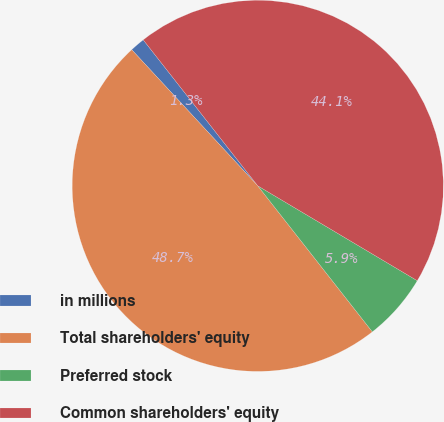Convert chart to OTSL. <chart><loc_0><loc_0><loc_500><loc_500><pie_chart><fcel>in millions<fcel>Total shareholders' equity<fcel>Preferred stock<fcel>Common shareholders' equity<nl><fcel>1.3%<fcel>48.7%<fcel>5.87%<fcel>44.13%<nl></chart> 